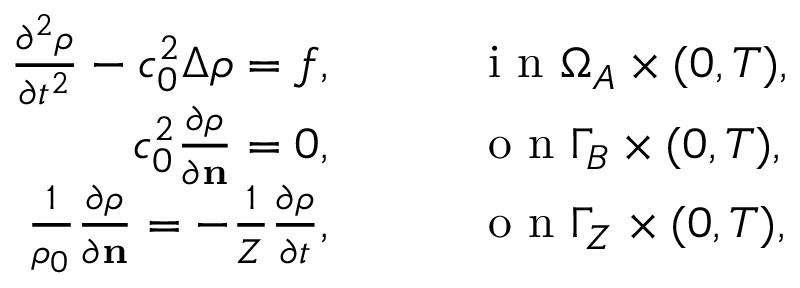<formula> <loc_0><loc_0><loc_500><loc_500>\begin{array} { r l } { \frac { \partial ^ { 2 } \rho } { \partial t ^ { 2 } } - c _ { 0 } ^ { 2 } \Delta \rho = f , } & \quad i n \Omega _ { A } \times ( 0 , T ) , } \\ { c _ { 0 } ^ { 2 } \frac { \partial \rho } { \partial n } = 0 , } & \quad o n \Gamma _ { B } \times ( 0 , T ) , } \\ { \frac { 1 } { \rho _ { 0 } } \frac { \partial \rho } { \partial n } = - \frac { 1 } { Z } \frac { \partial \rho } { \partial t } , } & \quad o n \Gamma _ { Z } \times ( 0 , T ) , } \end{array}</formula> 